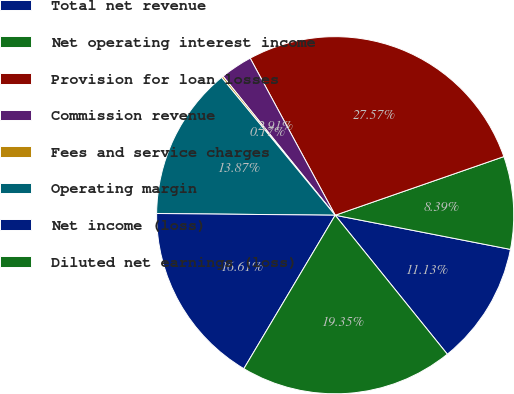Convert chart to OTSL. <chart><loc_0><loc_0><loc_500><loc_500><pie_chart><fcel>Total net revenue<fcel>Net operating interest income<fcel>Provision for loan losses<fcel>Commission revenue<fcel>Fees and service charges<fcel>Operating margin<fcel>Net income (loss)<fcel>Diluted net earnings (loss)<nl><fcel>11.13%<fcel>8.39%<fcel>27.57%<fcel>2.91%<fcel>0.17%<fcel>13.87%<fcel>16.61%<fcel>19.35%<nl></chart> 